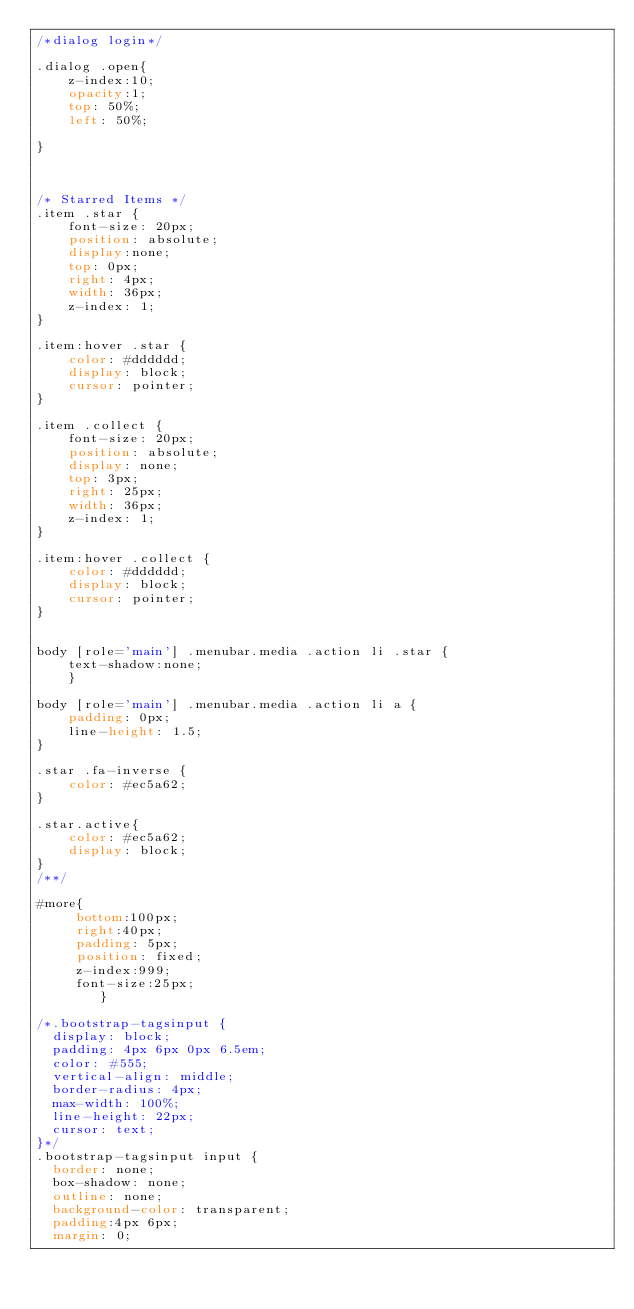Convert code to text. <code><loc_0><loc_0><loc_500><loc_500><_CSS_>/*dialog login*/

.dialog .open{
	z-index:10;
	opacity:1;
	top: 50%;
    left: 50%;
	
}



/* Starred Items */
.item .star {
	font-size: 20px;
	position: absolute;
	display:none;
	top: 0px;
	right: 4px;
	width: 36px;
	z-index: 1;
}

.item:hover .star {
	color: #dddddd;
	display: block;
	cursor: pointer;
}

.item .collect {
	font-size: 20px;
    position: absolute;
    display: none;
    top: 3px;
    right: 25px;
    width: 36px;
    z-index: 1;
}

.item:hover .collect {
	color: #dddddd;
	display: block;
	cursor: pointer;
}


body [role='main'] .menubar.media .action li .star {
	text-shadow:none;
	}

body [role='main'] .menubar.media .action li a {
    padding: 0px;
    line-height: 1.5;
}

.star .fa-inverse {
	color: #ec5a62;
}

.star.active{
	color: #ec5a62;
	display: block;
}
/**/

#more{
	 bottom:100px;
	 right:40px;
	 padding: 5px;
     position: fixed;
     z-index:999;
     font-size:25px;
	    }

/*.bootstrap-tagsinput {
  display: block;
  padding: 4px 6px 0px 6.5em;
  color: #555;
  vertical-align: middle;
  border-radius: 4px;
  max-width: 100%;
  line-height: 22px;
  cursor: text;
}*/
.bootstrap-tagsinput input {
  border: none;
  box-shadow: none;
  outline: none;
  background-color: transparent;
  padding:4px 6px;
  margin: 0;</code> 